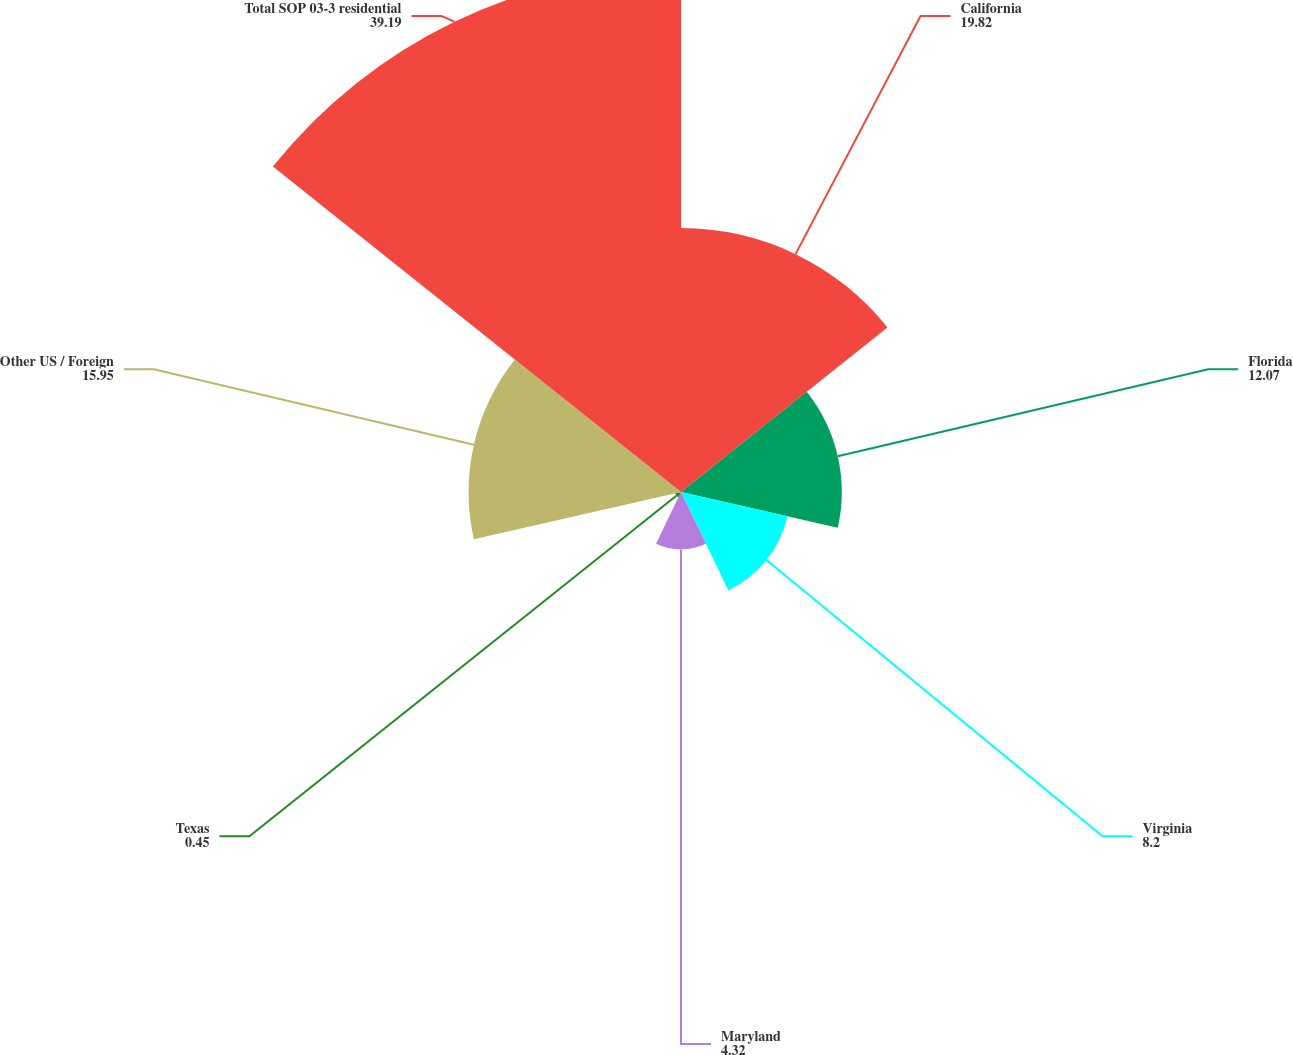Convert chart. <chart><loc_0><loc_0><loc_500><loc_500><pie_chart><fcel>California<fcel>Florida<fcel>Virginia<fcel>Maryland<fcel>Texas<fcel>Other US / Foreign<fcel>Total SOP 03-3 residential<nl><fcel>19.82%<fcel>12.07%<fcel>8.2%<fcel>4.32%<fcel>0.45%<fcel>15.95%<fcel>39.19%<nl></chart> 